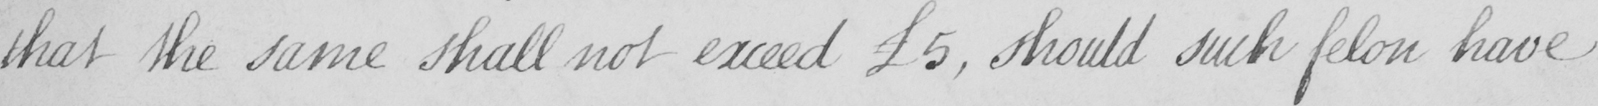Can you tell me what this handwritten text says? that the same shall not exceed £5 , should such felon have 